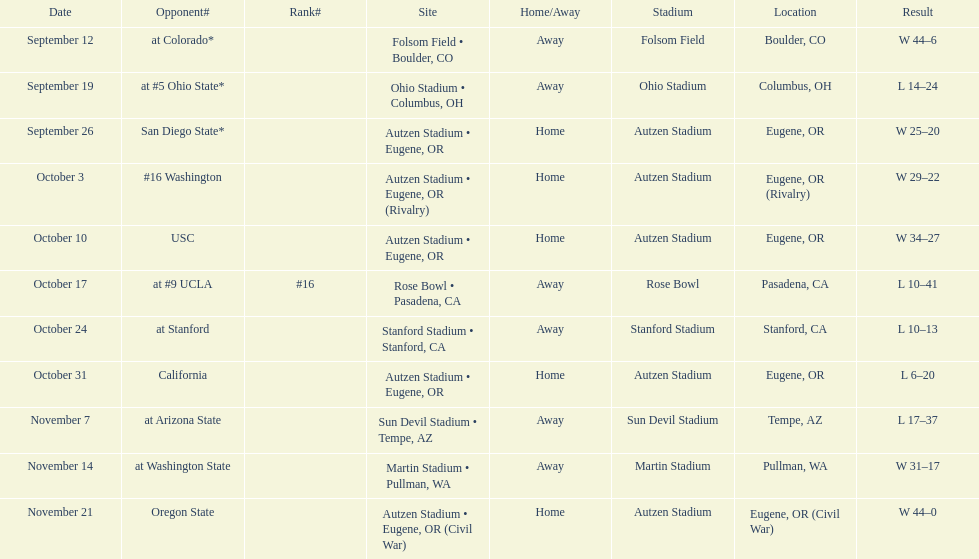What is the number of away games ? 6. 